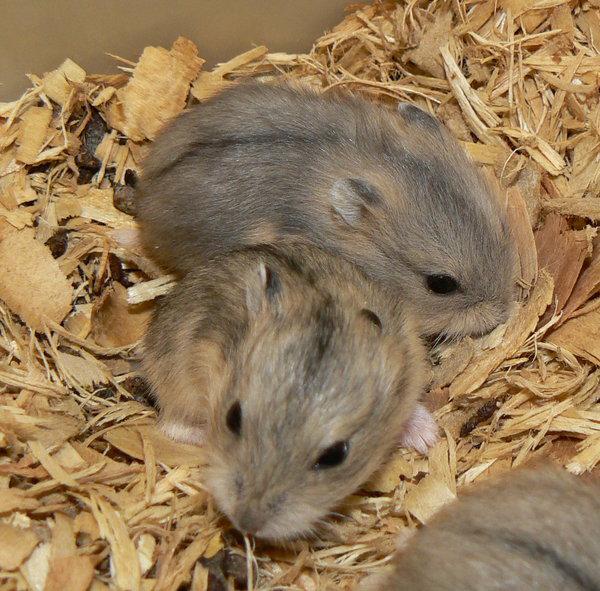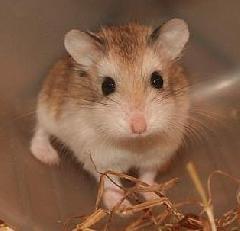The first image is the image on the left, the second image is the image on the right. Analyze the images presented: Is the assertion "There is a single animal in one image and at least two animals in the other." valid? Answer yes or no. Yes. The first image is the image on the left, the second image is the image on the right. For the images displayed, is the sentence "There are 3 hamsters in the image pair" factually correct? Answer yes or no. Yes. 